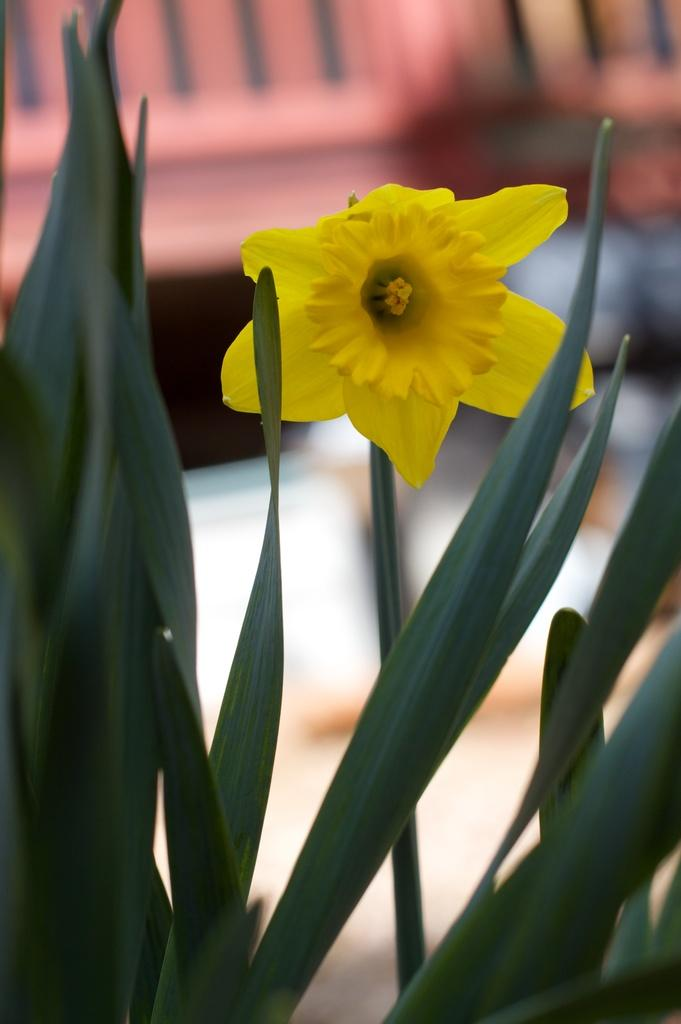What is present in the image that is related to nature? There is a plant in the image. What specific feature of the plant can be observed? The plant has a flower. What color is the flower? The flower is yellow. What can be seen in the background of the image? There is a red building in the background of the image. How is the building depicted in the image? The building is blurred. What note is the plant playing in the image? There is no indication in the image that the plant is playing a note, as plants do not have the ability to play musical instruments. 